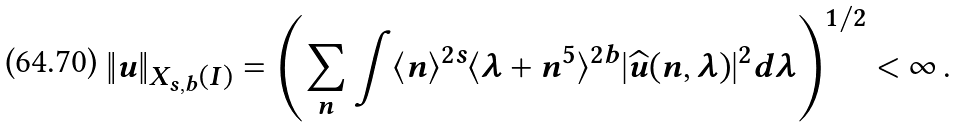<formula> <loc_0><loc_0><loc_500><loc_500>\| u \| _ { X _ { s , b } ( I ) } = \left ( \sum _ { n } \int \langle n \rangle ^ { 2 s } \langle \lambda + n ^ { 5 } \rangle ^ { 2 b } | \widehat { u } ( n , \lambda ) | ^ { 2 } d \lambda \right ) ^ { 1 / 2 } < \infty \, .</formula> 